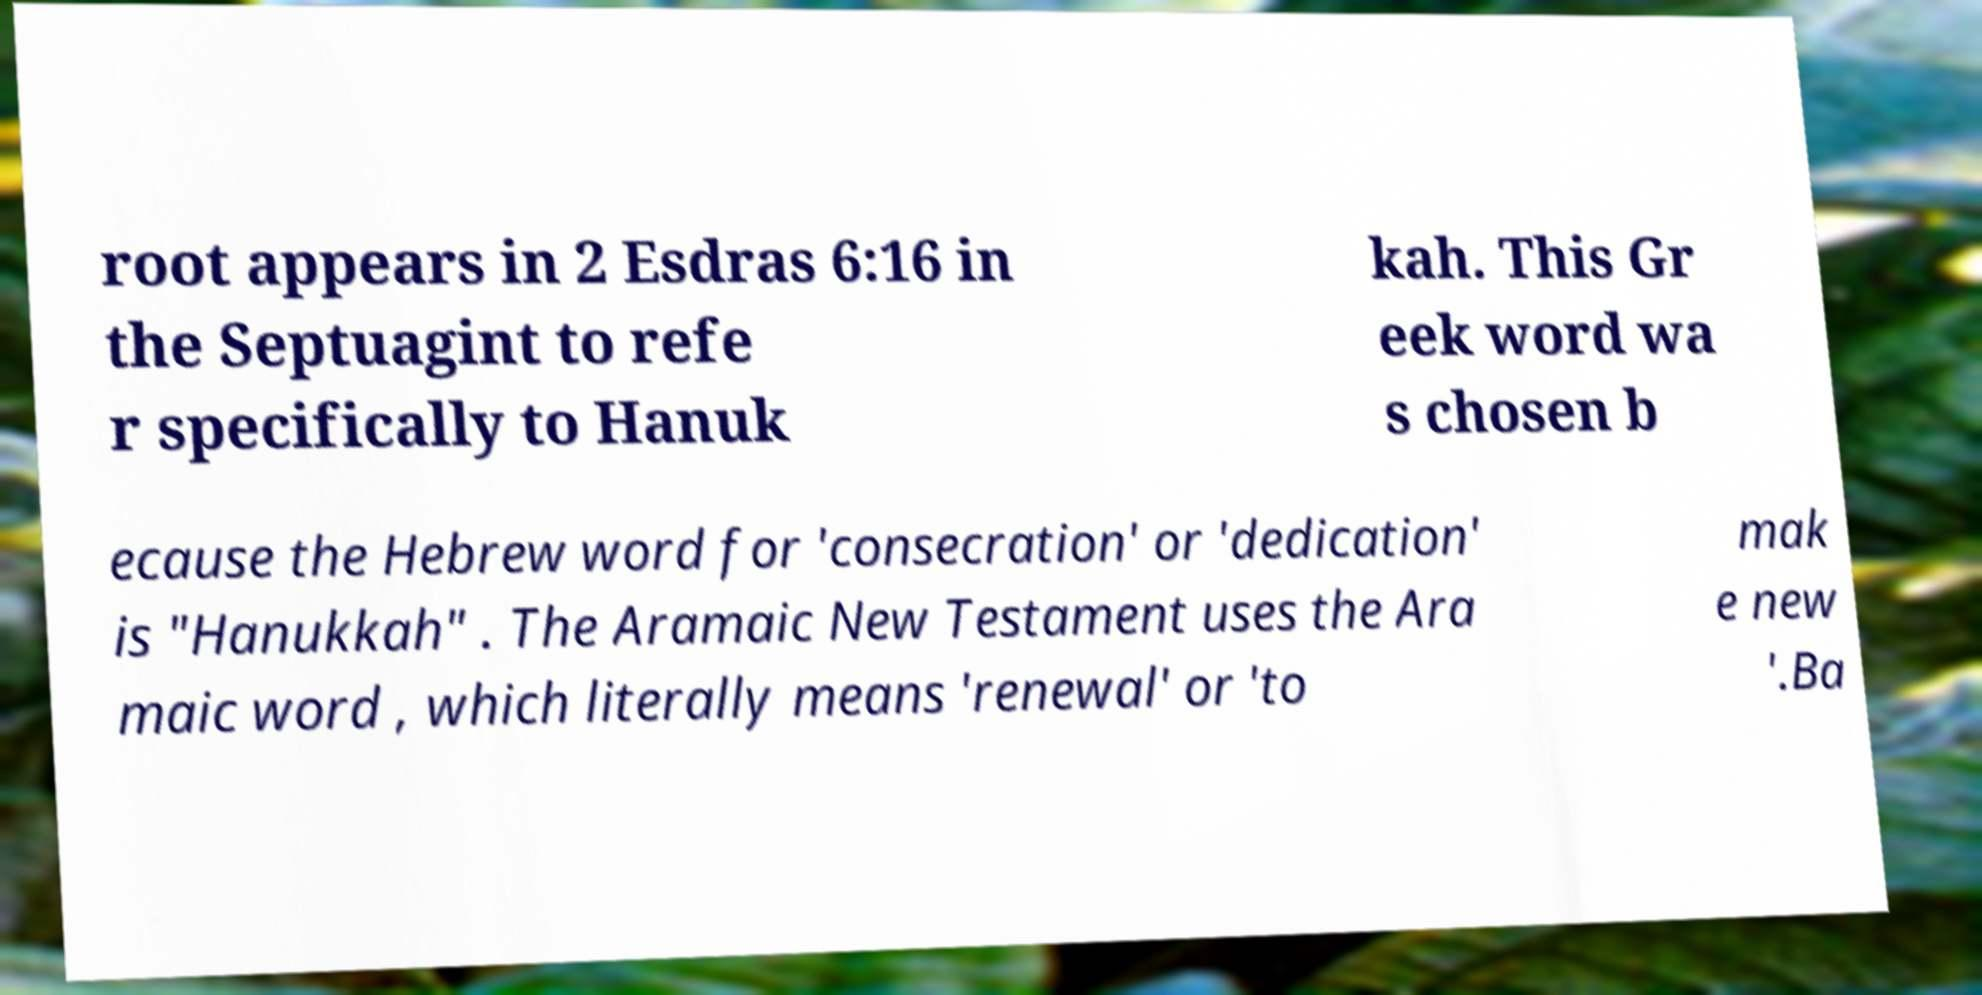For documentation purposes, I need the text within this image transcribed. Could you provide that? root appears in 2 Esdras 6:16 in the Septuagint to refe r specifically to Hanuk kah. This Gr eek word wa s chosen b ecause the Hebrew word for 'consecration' or 'dedication' is "Hanukkah" . The Aramaic New Testament uses the Ara maic word , which literally means 'renewal' or 'to mak e new '.Ba 